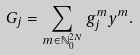Convert formula to latex. <formula><loc_0><loc_0><loc_500><loc_500>G _ { j } = \sum _ { m \in \mathbb { N } ^ { 2 N } _ { 0 } } g _ { j } ^ { m } y ^ { m } .</formula> 